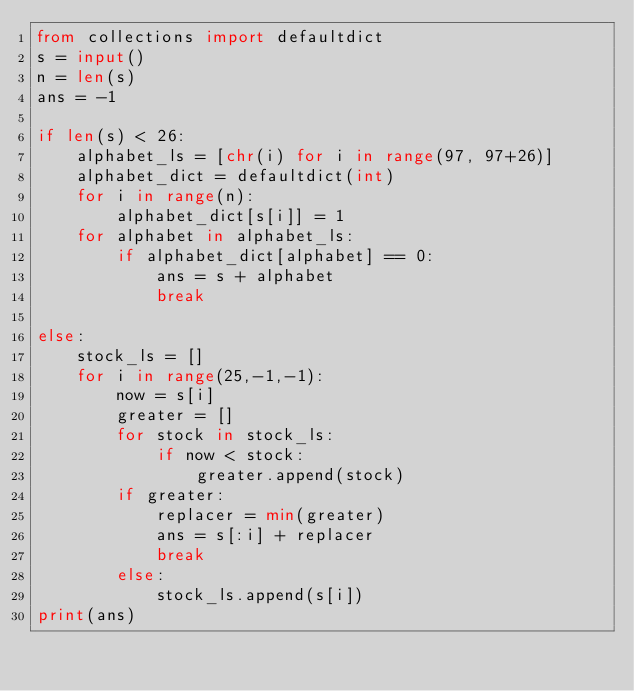<code> <loc_0><loc_0><loc_500><loc_500><_Python_>from collections import defaultdict
s = input()
n = len(s)
ans = -1

if len(s) < 26:
    alphabet_ls = [chr(i) for i in range(97, 97+26)]
    alphabet_dict = defaultdict(int)
    for i in range(n):
        alphabet_dict[s[i]] = 1
    for alphabet in alphabet_ls:
        if alphabet_dict[alphabet] == 0:
            ans = s + alphabet
            break

else:
    stock_ls = []
    for i in range(25,-1,-1):
        now = s[i]
        greater = []
        for stock in stock_ls:
            if now < stock:
                greater.append(stock)
        if greater:
            replacer = min(greater)
            ans = s[:i] + replacer
            break
        else:
            stock_ls.append(s[i])
print(ans)


</code> 